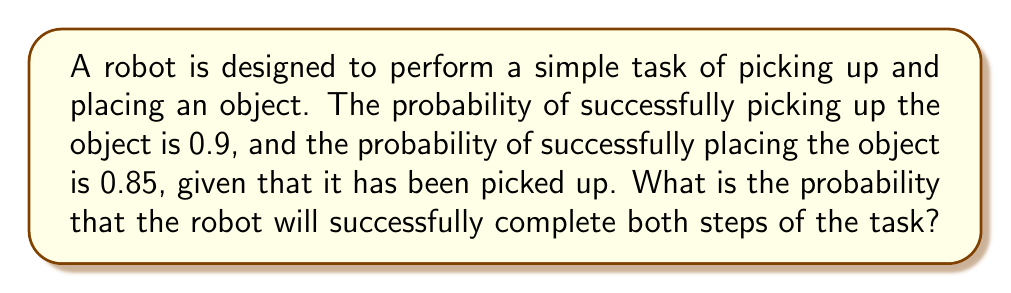Help me with this question. Let's approach this step-by-step:

1) We need to find the probability of two events occurring together:
   - Event A: Successfully picking up the object
   - Event B: Successfully placing the object (given that it has been picked up)

2) We're given:
   - P(A) = 0.9 (probability of picking up)
   - P(B|A) = 0.85 (probability of placing, given that it's been picked up)

3) To find the probability of both events occurring, we use the multiplication rule of probability:

   $$ P(A \text{ and } B) = P(A) \times P(B|A) $$

4) Substituting the values:

   $$ P(A \text{ and } B) = 0.9 \times 0.85 $$

5) Calculating:

   $$ P(A \text{ and } B) = 0.765 $$

Therefore, the probability that the robot will successfully complete both steps of the task is 0.765 or 76.5%.
Answer: 0.765 